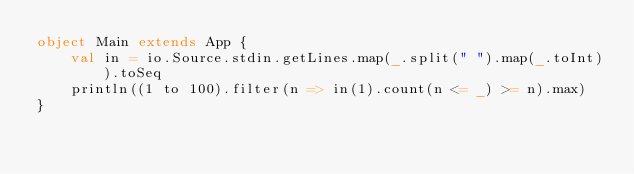Convert code to text. <code><loc_0><loc_0><loc_500><loc_500><_Scala_>object Main extends App {
    val in = io.Source.stdin.getLines.map(_.split(" ").map(_.toInt)).toSeq
    println((1 to 100).filter(n => in(1).count(n <= _) >= n).max)
}</code> 